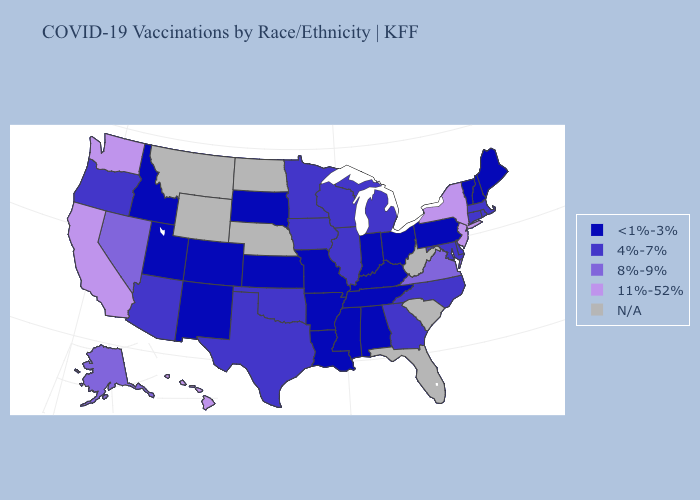Among the states that border Ohio , which have the highest value?
Concise answer only. Michigan. Does the map have missing data?
Quick response, please. Yes. Name the states that have a value in the range 8%-9%?
Concise answer only. Alaska, Nevada, Virginia. Does Pennsylvania have the lowest value in the USA?
Give a very brief answer. Yes. What is the value of Utah?
Answer briefly. <1%-3%. Which states have the lowest value in the USA?
Quick response, please. Alabama, Arkansas, Colorado, Idaho, Indiana, Kansas, Kentucky, Louisiana, Maine, Mississippi, Missouri, New Hampshire, New Mexico, Ohio, Pennsylvania, South Dakota, Tennessee, Utah, Vermont. What is the value of North Carolina?
Short answer required. 4%-7%. Among the states that border New Hampshire , does Massachusetts have the highest value?
Short answer required. Yes. Among the states that border Delaware , which have the lowest value?
Concise answer only. Pennsylvania. Which states have the lowest value in the USA?
Concise answer only. Alabama, Arkansas, Colorado, Idaho, Indiana, Kansas, Kentucky, Louisiana, Maine, Mississippi, Missouri, New Hampshire, New Mexico, Ohio, Pennsylvania, South Dakota, Tennessee, Utah, Vermont. Among the states that border Vermont , which have the highest value?
Answer briefly. New York. Does Texas have the lowest value in the USA?
Answer briefly. No. What is the highest value in the USA?
Answer briefly. 11%-52%. What is the value of Virginia?
Short answer required. 8%-9%. 